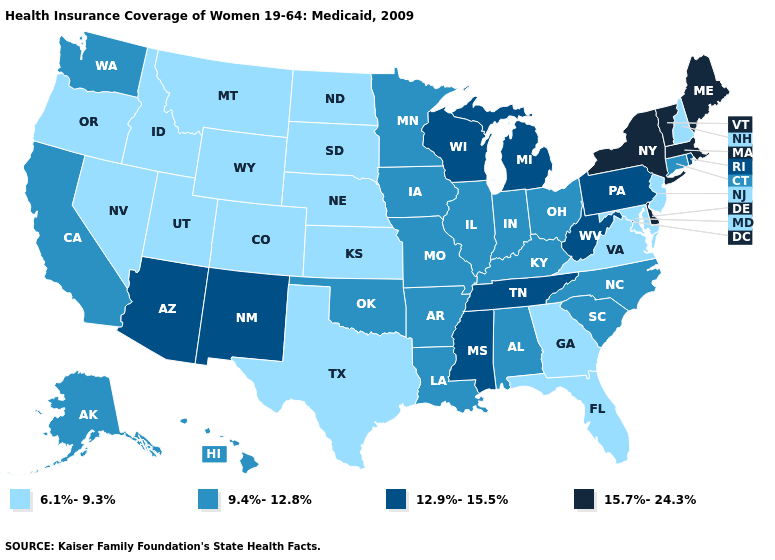Name the states that have a value in the range 9.4%-12.8%?
Concise answer only. Alabama, Alaska, Arkansas, California, Connecticut, Hawaii, Illinois, Indiana, Iowa, Kentucky, Louisiana, Minnesota, Missouri, North Carolina, Ohio, Oklahoma, South Carolina, Washington. Among the states that border Colorado , which have the lowest value?
Write a very short answer. Kansas, Nebraska, Utah, Wyoming. What is the value of Alaska?
Give a very brief answer. 9.4%-12.8%. Does Pennsylvania have a higher value than Connecticut?
Answer briefly. Yes. Is the legend a continuous bar?
Give a very brief answer. No. Does South Dakota have the lowest value in the MidWest?
Concise answer only. Yes. Which states have the lowest value in the West?
Short answer required. Colorado, Idaho, Montana, Nevada, Oregon, Utah, Wyoming. Which states have the lowest value in the USA?
Short answer required. Colorado, Florida, Georgia, Idaho, Kansas, Maryland, Montana, Nebraska, Nevada, New Hampshire, New Jersey, North Dakota, Oregon, South Dakota, Texas, Utah, Virginia, Wyoming. Among the states that border New Mexico , does Utah have the lowest value?
Answer briefly. Yes. Which states have the lowest value in the USA?
Concise answer only. Colorado, Florida, Georgia, Idaho, Kansas, Maryland, Montana, Nebraska, Nevada, New Hampshire, New Jersey, North Dakota, Oregon, South Dakota, Texas, Utah, Virginia, Wyoming. Does the first symbol in the legend represent the smallest category?
Be succinct. Yes. Which states have the lowest value in the West?
Quick response, please. Colorado, Idaho, Montana, Nevada, Oregon, Utah, Wyoming. What is the value of Oregon?
Keep it brief. 6.1%-9.3%. What is the value of Virginia?
Quick response, please. 6.1%-9.3%. What is the highest value in the MidWest ?
Write a very short answer. 12.9%-15.5%. 